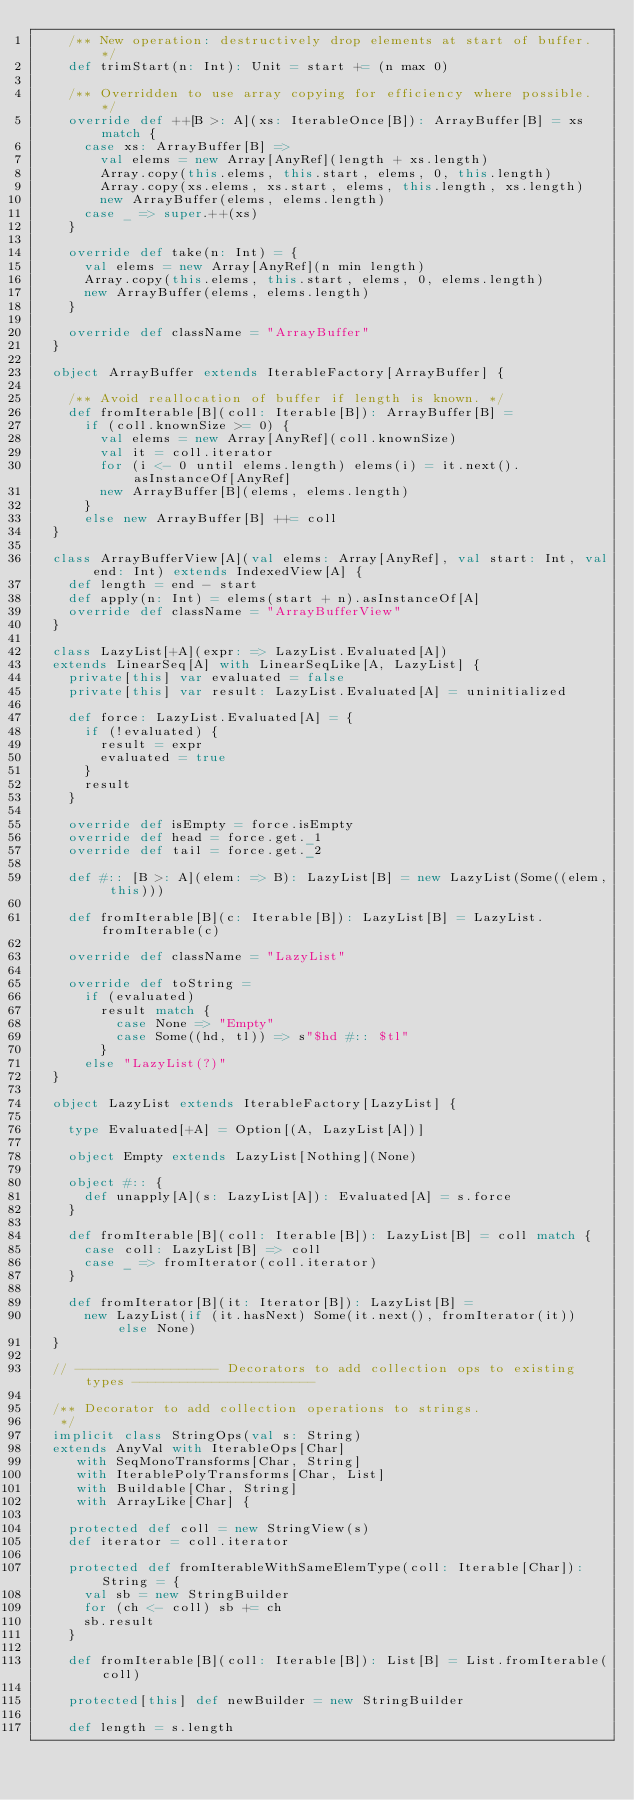<code> <loc_0><loc_0><loc_500><loc_500><_Scala_>    /** New operation: destructively drop elements at start of buffer. */
    def trimStart(n: Int): Unit = start += (n max 0)

    /** Overridden to use array copying for efficiency where possible. */
    override def ++[B >: A](xs: IterableOnce[B]): ArrayBuffer[B] = xs match {
      case xs: ArrayBuffer[B] =>
        val elems = new Array[AnyRef](length + xs.length)
        Array.copy(this.elems, this.start, elems, 0, this.length)
        Array.copy(xs.elems, xs.start, elems, this.length, xs.length)
        new ArrayBuffer(elems, elems.length)
      case _ => super.++(xs)
    }

    override def take(n: Int) = {
      val elems = new Array[AnyRef](n min length)
      Array.copy(this.elems, this.start, elems, 0, elems.length)
      new ArrayBuffer(elems, elems.length)
    }

    override def className = "ArrayBuffer"
  }

  object ArrayBuffer extends IterableFactory[ArrayBuffer] {

    /** Avoid reallocation of buffer if length is known. */
    def fromIterable[B](coll: Iterable[B]): ArrayBuffer[B] =
      if (coll.knownSize >= 0) {
        val elems = new Array[AnyRef](coll.knownSize)
        val it = coll.iterator
        for (i <- 0 until elems.length) elems(i) = it.next().asInstanceOf[AnyRef]
        new ArrayBuffer[B](elems, elems.length)
      }
      else new ArrayBuffer[B] ++= coll
  }

  class ArrayBufferView[A](val elems: Array[AnyRef], val start: Int, val end: Int) extends IndexedView[A] {
    def length = end - start
    def apply(n: Int) = elems(start + n).asInstanceOf[A]
    override def className = "ArrayBufferView"
  }

  class LazyList[+A](expr: => LazyList.Evaluated[A])
  extends LinearSeq[A] with LinearSeqLike[A, LazyList] {
    private[this] var evaluated = false
    private[this] var result: LazyList.Evaluated[A] = uninitialized

    def force: LazyList.Evaluated[A] = {
      if (!evaluated) {
        result = expr
        evaluated = true
      }
      result
    }

    override def isEmpty = force.isEmpty
    override def head = force.get._1
    override def tail = force.get._2

    def #:: [B >: A](elem: => B): LazyList[B] = new LazyList(Some((elem, this)))

    def fromIterable[B](c: Iterable[B]): LazyList[B] = LazyList.fromIterable(c)

    override def className = "LazyList"

    override def toString =
      if (evaluated)
        result match {
          case None => "Empty"
          case Some((hd, tl)) => s"$hd #:: $tl"
        }
      else "LazyList(?)"
  }

  object LazyList extends IterableFactory[LazyList] {

    type Evaluated[+A] = Option[(A, LazyList[A])]

    object Empty extends LazyList[Nothing](None)

    object #:: {
      def unapply[A](s: LazyList[A]): Evaluated[A] = s.force
    }

    def fromIterable[B](coll: Iterable[B]): LazyList[B] = coll match {
      case coll: LazyList[B] => coll
      case _ => fromIterator(coll.iterator)
    }

    def fromIterator[B](it: Iterator[B]): LazyList[B] =
      new LazyList(if (it.hasNext) Some(it.next(), fromIterator(it)) else None)
  }

  // ------------------ Decorators to add collection ops to existing types -----------------------

  /** Decorator to add collection operations to strings.
   */
  implicit class StringOps(val s: String)
  extends AnyVal with IterableOps[Char]
     with SeqMonoTransforms[Char, String]
     with IterablePolyTransforms[Char, List]
     with Buildable[Char, String]
     with ArrayLike[Char] {

    protected def coll = new StringView(s)
    def iterator = coll.iterator

    protected def fromIterableWithSameElemType(coll: Iterable[Char]): String = {
      val sb = new StringBuilder
      for (ch <- coll) sb += ch
      sb.result
    }

    def fromIterable[B](coll: Iterable[B]): List[B] = List.fromIterable(coll)

    protected[this] def newBuilder = new StringBuilder

    def length = s.length</code> 